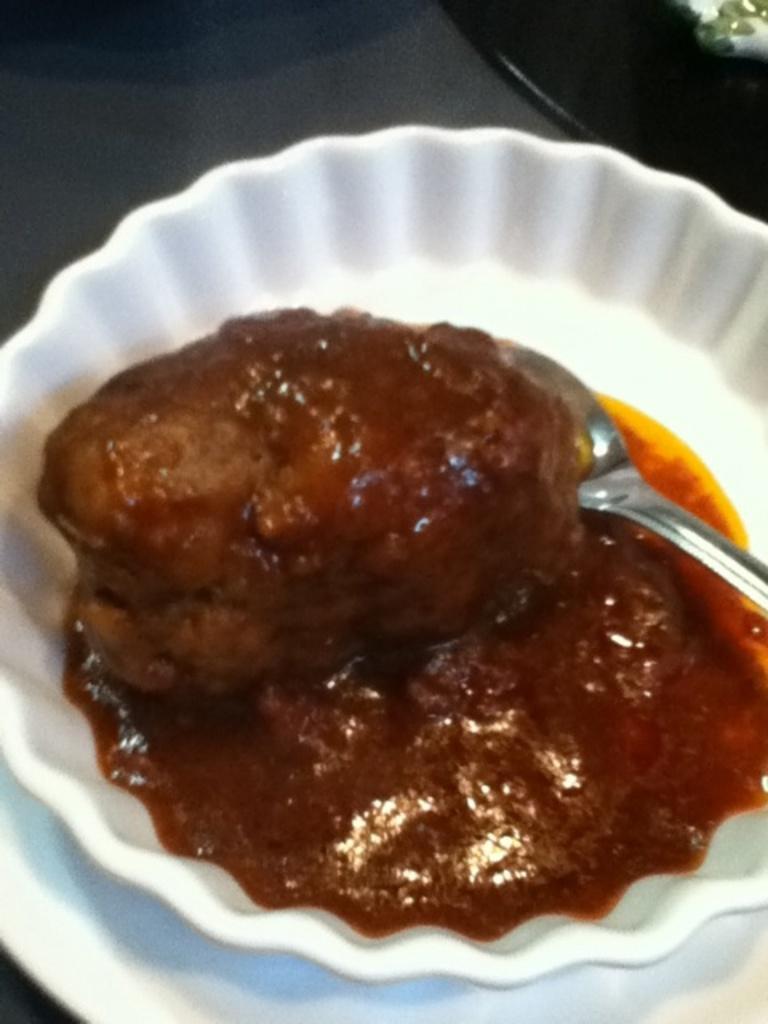How would you summarize this image in a sentence or two? In this image, I can see a bowl on a plate. This bowl contains a food item. I think this is a spoon. At the top right corner of the image, that looks like an object. 